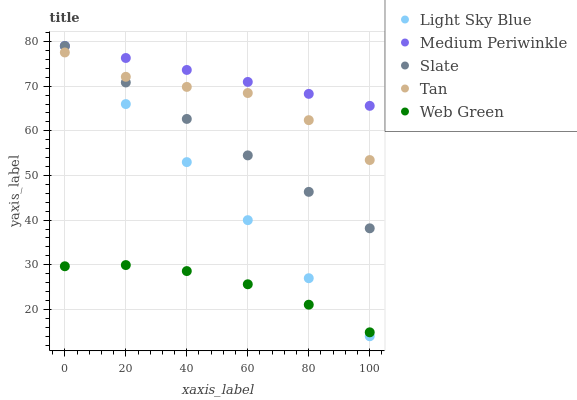Does Web Green have the minimum area under the curve?
Answer yes or no. Yes. Does Medium Periwinkle have the maximum area under the curve?
Answer yes or no. Yes. Does Light Sky Blue have the minimum area under the curve?
Answer yes or no. No. Does Light Sky Blue have the maximum area under the curve?
Answer yes or no. No. Is Light Sky Blue the smoothest?
Answer yes or no. Yes. Is Tan the roughest?
Answer yes or no. Yes. Is Tan the smoothest?
Answer yes or no. No. Is Medium Periwinkle the roughest?
Answer yes or no. No. Does Light Sky Blue have the lowest value?
Answer yes or no. Yes. Does Medium Periwinkle have the lowest value?
Answer yes or no. No. Does Medium Periwinkle have the highest value?
Answer yes or no. Yes. Does Tan have the highest value?
Answer yes or no. No. Is Web Green less than Slate?
Answer yes or no. Yes. Is Tan greater than Web Green?
Answer yes or no. Yes. Does Slate intersect Tan?
Answer yes or no. Yes. Is Slate less than Tan?
Answer yes or no. No. Is Slate greater than Tan?
Answer yes or no. No. Does Web Green intersect Slate?
Answer yes or no. No. 